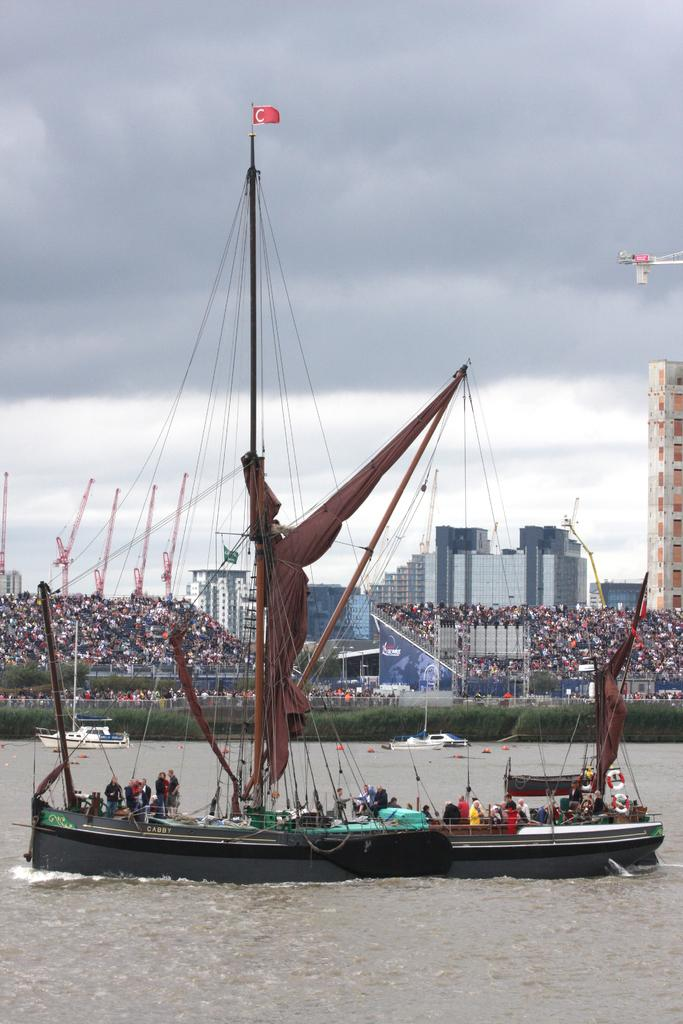What type of ship is in the image? There is a trireme in the image. Are there any people on the ship? Yes, there are people in the trireme. What can be seen in the background of the image? There are people and buildings in the background of the image. What type of shoe is the tiger wearing in the image? There is no tiger or shoe present in the image. 